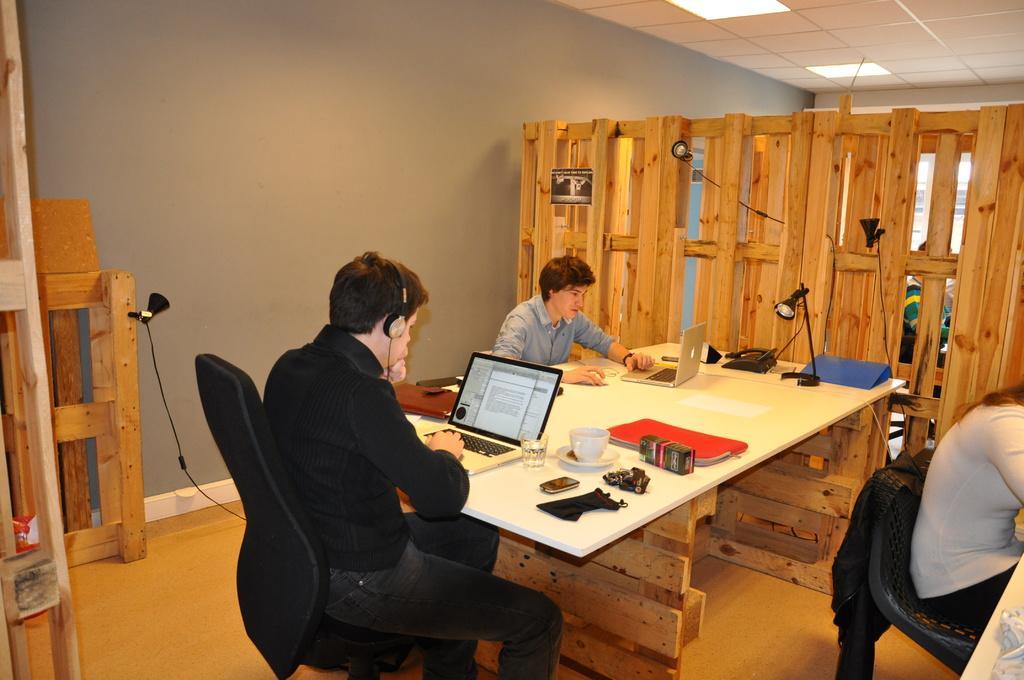How would you summarize this image in a sentence or two? There is a room in which there is a chair. One of the guy is sitting in the chair looking into the laptop using a headset. Laptop is on the table. There are some accessories on the table. Another guy is sitting to the left of this guy. We can observe a wooden wall here. And in the background we can see a wall and ceiling lights. there is a woman sitting in the right side. 